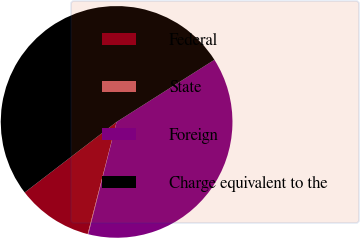Convert chart to OTSL. <chart><loc_0><loc_0><loc_500><loc_500><pie_chart><fcel>Federal<fcel>State<fcel>Foreign<fcel>Charge equivalent to the<nl><fcel>10.56%<fcel>0.09%<fcel>37.93%<fcel>51.41%<nl></chart> 